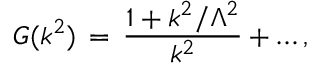<formula> <loc_0><loc_0><loc_500><loc_500>G ( k ^ { 2 } ) \, = \, \frac { 1 + k ^ { 2 } / \Lambda ^ { 2 } } { k ^ { 2 } } + \dots ,</formula> 